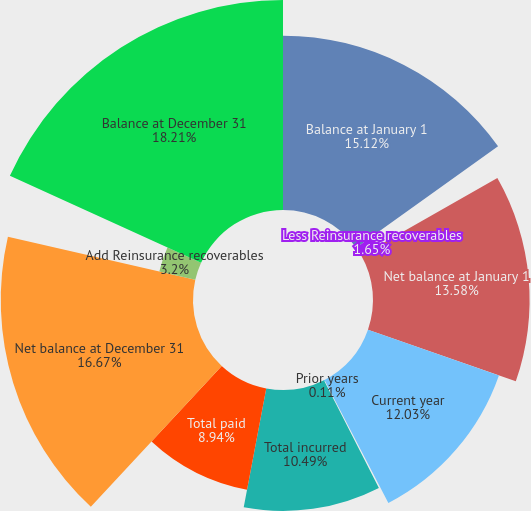<chart> <loc_0><loc_0><loc_500><loc_500><pie_chart><fcel>Balance at January 1<fcel>Less Reinsurance recoverables<fcel>Net balance at January 1<fcel>Current year<fcel>Prior years<fcel>Total incurred<fcel>Total paid<fcel>Net balance at December 31<fcel>Add Reinsurance recoverables<fcel>Balance at December 31<nl><fcel>15.12%<fcel>1.65%<fcel>13.58%<fcel>12.03%<fcel>0.11%<fcel>10.49%<fcel>8.94%<fcel>16.67%<fcel>3.2%<fcel>18.21%<nl></chart> 